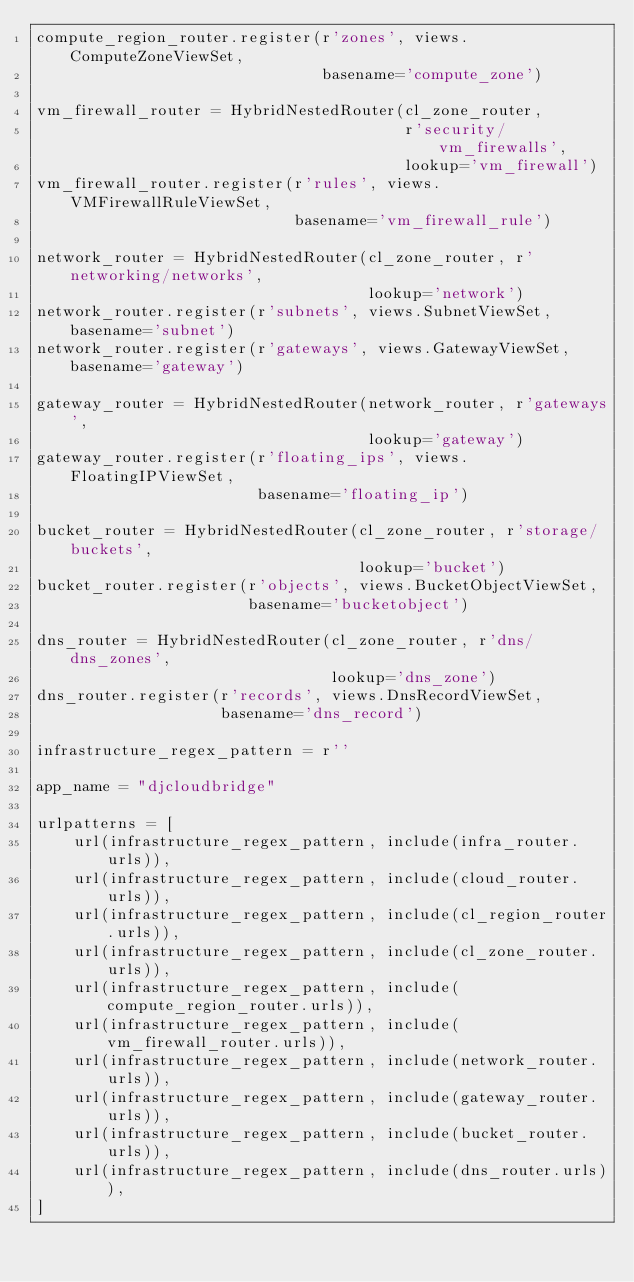Convert code to text. <code><loc_0><loc_0><loc_500><loc_500><_Python_>compute_region_router.register(r'zones', views.ComputeZoneViewSet,
                               basename='compute_zone')

vm_firewall_router = HybridNestedRouter(cl_zone_router,
                                        r'security/vm_firewalls',
                                        lookup='vm_firewall')
vm_firewall_router.register(r'rules', views.VMFirewallRuleViewSet,
                            basename='vm_firewall_rule')

network_router = HybridNestedRouter(cl_zone_router, r'networking/networks',
                                    lookup='network')
network_router.register(r'subnets', views.SubnetViewSet, basename='subnet')
network_router.register(r'gateways', views.GatewayViewSet, basename='gateway')

gateway_router = HybridNestedRouter(network_router, r'gateways',
                                    lookup='gateway')
gateway_router.register(r'floating_ips', views.FloatingIPViewSet,
                        basename='floating_ip')

bucket_router = HybridNestedRouter(cl_zone_router, r'storage/buckets',
                                   lookup='bucket')
bucket_router.register(r'objects', views.BucketObjectViewSet,
                       basename='bucketobject')

dns_router = HybridNestedRouter(cl_zone_router, r'dns/dns_zones',
                                lookup='dns_zone')
dns_router.register(r'records', views.DnsRecordViewSet,
                    basename='dns_record')

infrastructure_regex_pattern = r''

app_name = "djcloudbridge"

urlpatterns = [
    url(infrastructure_regex_pattern, include(infra_router.urls)),
    url(infrastructure_regex_pattern, include(cloud_router.urls)),
    url(infrastructure_regex_pattern, include(cl_region_router.urls)),
    url(infrastructure_regex_pattern, include(cl_zone_router.urls)),
    url(infrastructure_regex_pattern, include(compute_region_router.urls)),
    url(infrastructure_regex_pattern, include(vm_firewall_router.urls)),
    url(infrastructure_regex_pattern, include(network_router.urls)),
    url(infrastructure_regex_pattern, include(gateway_router.urls)),
    url(infrastructure_regex_pattern, include(bucket_router.urls)),
    url(infrastructure_regex_pattern, include(dns_router.urls)),
]
</code> 